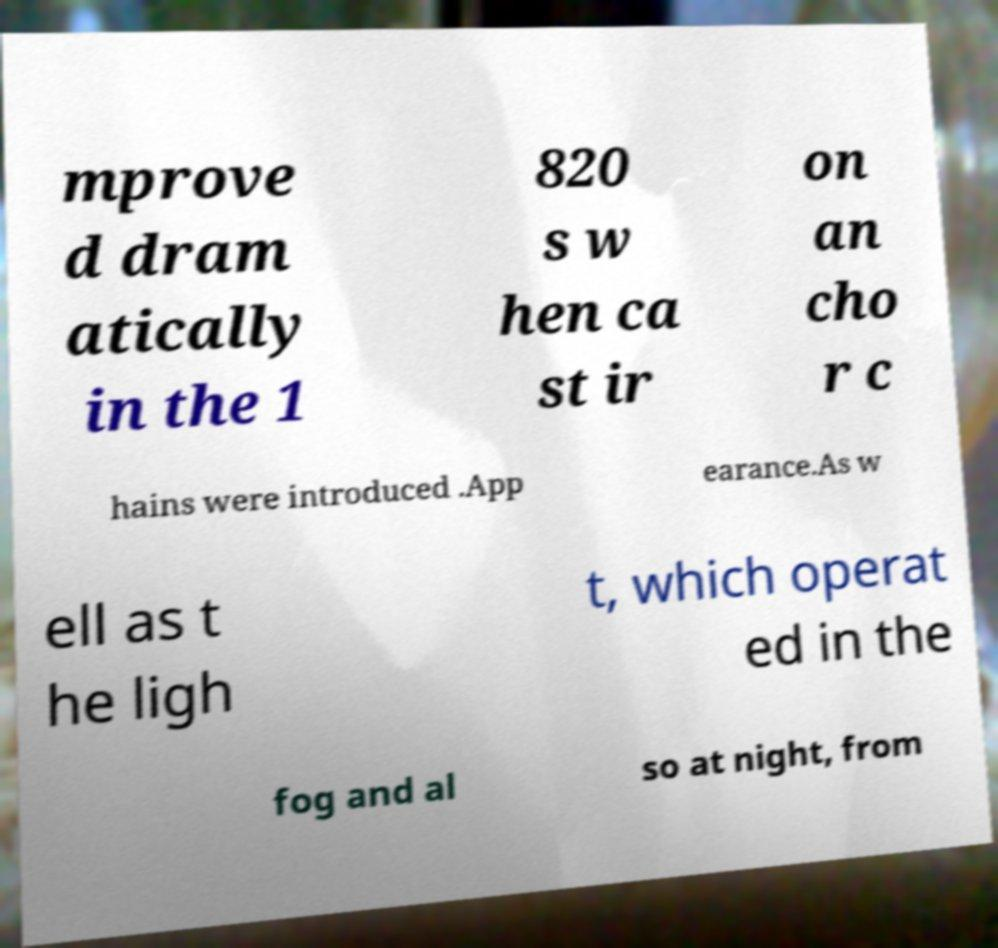Please identify and transcribe the text found in this image. mprove d dram atically in the 1 820 s w hen ca st ir on an cho r c hains were introduced .App earance.As w ell as t he ligh t, which operat ed in the fog and al so at night, from 